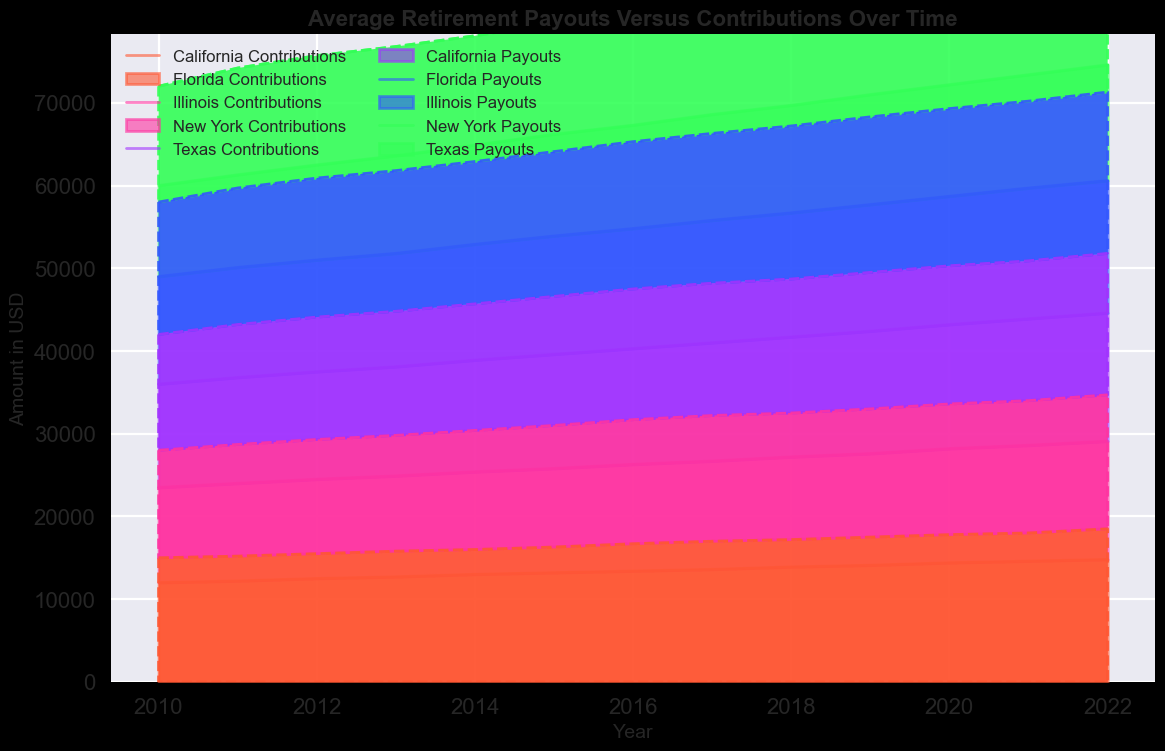Which state had higher average contributions in 2015, California or Texas? By looking at the area corresponding to contributions in 2015, California's contributions are higher than Texas's. California's contribution is $13200, while Texas's is $12300.
Answer: California What is the difference in average payouts between New York and Illinois in 2020? In the year 2020, New York's payout is $19000 and Illinois's payout is $16700. The difference between these payouts is $19000 - $16700 = $2300.
Answer: $2300 How did average contributions for California change from 2010 to 2022? In 2010, the average contribution for California was $12000, and in 2022, it is $14800. Therefore, the change is $14800 - $12000 = $2800.
Answer: Increase by $2800 Which state had a consistently increasing trend in both contributions and payouts between 2010 and 2022? Observing the trends from 2010 to 2022, New York shows a consistent increase in both contributions and payouts throughout the period without any dips.
Answer: New York Compare the average payout trends between California and Florida. Which state had more significant increases? Analyzing the area chart, California shows a more significant increase in payouts from $15000 in 2010 to $18500 in 2022, whereas Florida's payouts increased from $13000 in 2010 to $16200 in 2022. California has a $3500 increase, whereas Florida has a $3200 increase, indicating California's larger increase.
Answer: California What is the total average contribution across all states in 2017? Summing the contributions from California ($13600), Texas ($12800), New York ($14800), Florida ($13100), and Illinois ($14300) gives a total of $13600 + $12800 + $14800 + $13100 + $14300 = $68600.
Answer: $68600 Which state had the highest average payout in 2018, and what was the amount? By referencing the figure for 2018, New York had the highest payout at $18500.
Answer: New York, $18500 Identify the year when Texas's average payout first reached $16000. Referring to the payout data for Texas, the payout first reached $16000 in the year 2017.
Answer: 2017 What is the relative difference between average contributions and payouts for Illinois in 2021? For Illinois in 2021, the average contribution is $15300 and the payout is $16900. Relative difference = ($16900 - $15300) / $15300 = 1600 / 15300 ≈ 0.1046 or 10.46%.
Answer: 10.46% Which state's contribution increased the least from 2010 to 2022? Comparing the contributions in 2010 and 2022, Texas increased from $11000 to $14000 which is the smallest increase of $3000.
Answer: Texas 